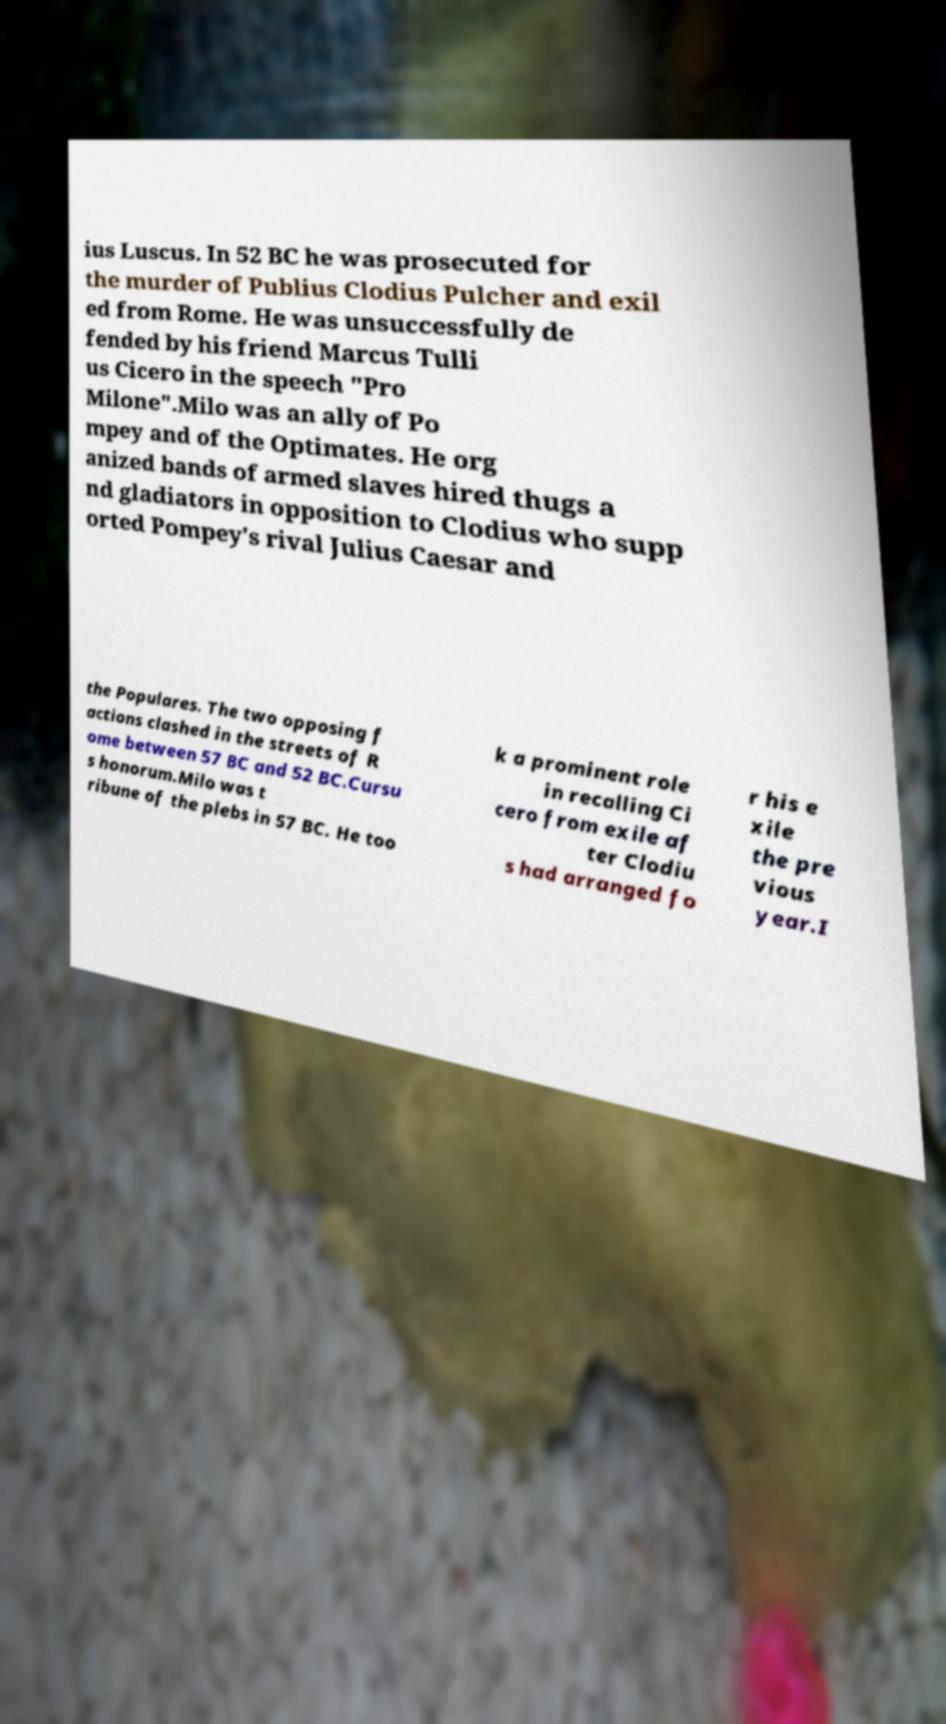What messages or text are displayed in this image? I need them in a readable, typed format. ius Luscus. In 52 BC he was prosecuted for the murder of Publius Clodius Pulcher and exil ed from Rome. He was unsuccessfully de fended by his friend Marcus Tulli us Cicero in the speech "Pro Milone".Milo was an ally of Po mpey and of the Optimates. He org anized bands of armed slaves hired thugs a nd gladiators in opposition to Clodius who supp orted Pompey's rival Julius Caesar and the Populares. The two opposing f actions clashed in the streets of R ome between 57 BC and 52 BC.Cursu s honorum.Milo was t ribune of the plebs in 57 BC. He too k a prominent role in recalling Ci cero from exile af ter Clodiu s had arranged fo r his e xile the pre vious year.I 